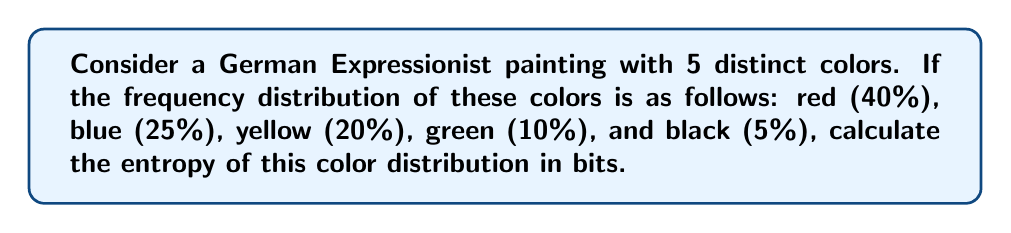Give your solution to this math problem. To calculate the entropy of the color distribution, we'll use the Shannon entropy formula:

$$ S = -\sum_{i=1}^{n} p_i \log_2(p_i) $$

Where $S$ is the entropy, $p_i$ is the probability of each color, and $n$ is the number of colors.

Step 1: Convert percentages to probabilities
Red: $p_1 = 0.40$
Blue: $p_2 = 0.25$
Yellow: $p_3 = 0.20$
Green: $p_4 = 0.10$
Black: $p_5 = 0.05$

Step 2: Calculate each term in the sum
Red: $-0.40 \log_2(0.40) = 0.5288$
Blue: $-0.25 \log_2(0.25) = 0.5000$
Yellow: $-0.20 \log_2(0.20) = 0.4644$
Green: $-0.10 \log_2(0.10) = 0.3322$
Black: $-0.05 \log_2(0.05) = 0.2161$

Step 3: Sum all terms
$$ S = 0.5288 + 0.5000 + 0.4644 + 0.3322 + 0.2161 = 2.0415 $$

Therefore, the entropy of the color distribution is approximately 2.0415 bits.
Answer: 2.0415 bits 